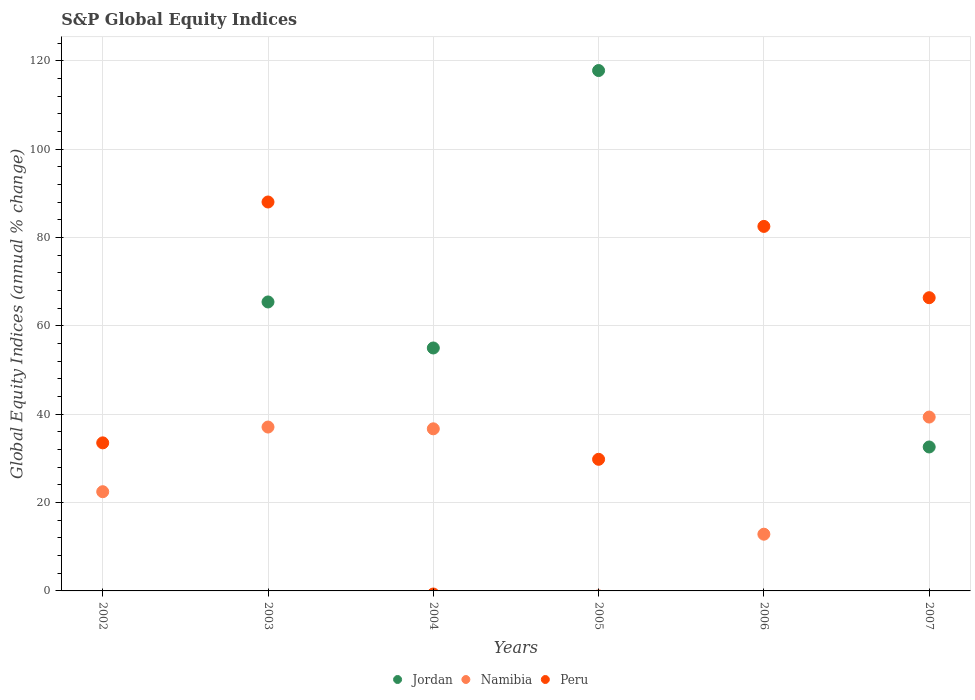How many different coloured dotlines are there?
Provide a short and direct response. 3. Is the number of dotlines equal to the number of legend labels?
Keep it short and to the point. No. Across all years, what is the maximum global equity indices in Namibia?
Make the answer very short. 39.36. What is the total global equity indices in Peru in the graph?
Your answer should be compact. 300.28. What is the difference between the global equity indices in Jordan in 2003 and that in 2004?
Your answer should be very brief. 10.42. What is the difference between the global equity indices in Namibia in 2006 and the global equity indices in Peru in 2007?
Provide a succinct answer. -53.54. What is the average global equity indices in Peru per year?
Make the answer very short. 50.05. In the year 2003, what is the difference between the global equity indices in Namibia and global equity indices in Jordan?
Offer a terse response. -28.32. What is the ratio of the global equity indices in Peru in 2002 to that in 2006?
Give a very brief answer. 0.41. Is the global equity indices in Jordan in 2003 less than that in 2005?
Your answer should be compact. Yes. What is the difference between the highest and the second highest global equity indices in Peru?
Your answer should be compact. 5.52. What is the difference between the highest and the lowest global equity indices in Jordan?
Give a very brief answer. 117.81. Is the sum of the global equity indices in Jordan in 2003 and 2004 greater than the maximum global equity indices in Peru across all years?
Keep it short and to the point. Yes. Is it the case that in every year, the sum of the global equity indices in Namibia and global equity indices in Jordan  is greater than the global equity indices in Peru?
Make the answer very short. No. Does the graph contain grids?
Ensure brevity in your answer.  Yes. Where does the legend appear in the graph?
Offer a very short reply. Bottom center. How many legend labels are there?
Provide a short and direct response. 3. What is the title of the graph?
Offer a very short reply. S&P Global Equity Indices. Does "Venezuela" appear as one of the legend labels in the graph?
Give a very brief answer. No. What is the label or title of the Y-axis?
Give a very brief answer. Global Equity Indices (annual % change). What is the Global Equity Indices (annual % change) in Jordan in 2002?
Provide a succinct answer. 0. What is the Global Equity Indices (annual % change) in Namibia in 2002?
Provide a short and direct response. 22.46. What is the Global Equity Indices (annual % change) in Peru in 2002?
Your answer should be compact. 33.52. What is the Global Equity Indices (annual % change) of Jordan in 2003?
Provide a succinct answer. 65.42. What is the Global Equity Indices (annual % change) in Namibia in 2003?
Provide a short and direct response. 37.1. What is the Global Equity Indices (annual % change) of Peru in 2003?
Offer a very short reply. 88.05. What is the Global Equity Indices (annual % change) in Jordan in 2004?
Offer a very short reply. 55. What is the Global Equity Indices (annual % change) of Namibia in 2004?
Provide a short and direct response. 36.7. What is the Global Equity Indices (annual % change) in Jordan in 2005?
Ensure brevity in your answer.  117.81. What is the Global Equity Indices (annual % change) in Namibia in 2005?
Your answer should be compact. 0. What is the Global Equity Indices (annual % change) of Peru in 2005?
Your response must be concise. 29.8. What is the Global Equity Indices (annual % change) of Namibia in 2006?
Offer a very short reply. 12.84. What is the Global Equity Indices (annual % change) of Peru in 2006?
Give a very brief answer. 82.53. What is the Global Equity Indices (annual % change) in Jordan in 2007?
Offer a very short reply. 32.59. What is the Global Equity Indices (annual % change) of Namibia in 2007?
Provide a succinct answer. 39.36. What is the Global Equity Indices (annual % change) of Peru in 2007?
Make the answer very short. 66.38. Across all years, what is the maximum Global Equity Indices (annual % change) in Jordan?
Provide a succinct answer. 117.81. Across all years, what is the maximum Global Equity Indices (annual % change) in Namibia?
Keep it short and to the point. 39.36. Across all years, what is the maximum Global Equity Indices (annual % change) of Peru?
Your answer should be compact. 88.05. Across all years, what is the minimum Global Equity Indices (annual % change) in Jordan?
Ensure brevity in your answer.  0. What is the total Global Equity Indices (annual % change) in Jordan in the graph?
Provide a short and direct response. 270.82. What is the total Global Equity Indices (annual % change) in Namibia in the graph?
Offer a very short reply. 148.46. What is the total Global Equity Indices (annual % change) in Peru in the graph?
Provide a short and direct response. 300.28. What is the difference between the Global Equity Indices (annual % change) in Namibia in 2002 and that in 2003?
Provide a short and direct response. -14.64. What is the difference between the Global Equity Indices (annual % change) of Peru in 2002 and that in 2003?
Offer a very short reply. -54.53. What is the difference between the Global Equity Indices (annual % change) in Namibia in 2002 and that in 2004?
Your answer should be very brief. -14.24. What is the difference between the Global Equity Indices (annual % change) of Peru in 2002 and that in 2005?
Offer a very short reply. 3.72. What is the difference between the Global Equity Indices (annual % change) of Namibia in 2002 and that in 2006?
Keep it short and to the point. 9.62. What is the difference between the Global Equity Indices (annual % change) of Peru in 2002 and that in 2006?
Your answer should be compact. -49.01. What is the difference between the Global Equity Indices (annual % change) in Namibia in 2002 and that in 2007?
Your answer should be very brief. -16.9. What is the difference between the Global Equity Indices (annual % change) in Peru in 2002 and that in 2007?
Provide a short and direct response. -32.86. What is the difference between the Global Equity Indices (annual % change) of Jordan in 2003 and that in 2004?
Offer a very short reply. 10.42. What is the difference between the Global Equity Indices (annual % change) in Jordan in 2003 and that in 2005?
Provide a succinct answer. -52.39. What is the difference between the Global Equity Indices (annual % change) of Peru in 2003 and that in 2005?
Offer a terse response. 58.25. What is the difference between the Global Equity Indices (annual % change) in Namibia in 2003 and that in 2006?
Keep it short and to the point. 24.26. What is the difference between the Global Equity Indices (annual % change) in Peru in 2003 and that in 2006?
Your answer should be compact. 5.52. What is the difference between the Global Equity Indices (annual % change) in Jordan in 2003 and that in 2007?
Ensure brevity in your answer.  32.83. What is the difference between the Global Equity Indices (annual % change) of Namibia in 2003 and that in 2007?
Give a very brief answer. -2.26. What is the difference between the Global Equity Indices (annual % change) of Peru in 2003 and that in 2007?
Your response must be concise. 21.67. What is the difference between the Global Equity Indices (annual % change) of Jordan in 2004 and that in 2005?
Offer a terse response. -62.81. What is the difference between the Global Equity Indices (annual % change) of Namibia in 2004 and that in 2006?
Your response must be concise. 23.86. What is the difference between the Global Equity Indices (annual % change) of Jordan in 2004 and that in 2007?
Provide a succinct answer. 22.41. What is the difference between the Global Equity Indices (annual % change) in Namibia in 2004 and that in 2007?
Give a very brief answer. -2.66. What is the difference between the Global Equity Indices (annual % change) of Peru in 2005 and that in 2006?
Provide a succinct answer. -52.73. What is the difference between the Global Equity Indices (annual % change) of Jordan in 2005 and that in 2007?
Offer a very short reply. 85.23. What is the difference between the Global Equity Indices (annual % change) of Peru in 2005 and that in 2007?
Provide a succinct answer. -36.59. What is the difference between the Global Equity Indices (annual % change) of Namibia in 2006 and that in 2007?
Offer a terse response. -26.52. What is the difference between the Global Equity Indices (annual % change) in Peru in 2006 and that in 2007?
Offer a terse response. 16.14. What is the difference between the Global Equity Indices (annual % change) in Namibia in 2002 and the Global Equity Indices (annual % change) in Peru in 2003?
Provide a succinct answer. -65.59. What is the difference between the Global Equity Indices (annual % change) in Namibia in 2002 and the Global Equity Indices (annual % change) in Peru in 2005?
Your answer should be very brief. -7.34. What is the difference between the Global Equity Indices (annual % change) of Namibia in 2002 and the Global Equity Indices (annual % change) of Peru in 2006?
Your answer should be compact. -60.07. What is the difference between the Global Equity Indices (annual % change) in Namibia in 2002 and the Global Equity Indices (annual % change) in Peru in 2007?
Provide a short and direct response. -43.92. What is the difference between the Global Equity Indices (annual % change) in Jordan in 2003 and the Global Equity Indices (annual % change) in Namibia in 2004?
Provide a short and direct response. 28.72. What is the difference between the Global Equity Indices (annual % change) of Jordan in 2003 and the Global Equity Indices (annual % change) of Peru in 2005?
Ensure brevity in your answer.  35.62. What is the difference between the Global Equity Indices (annual % change) of Namibia in 2003 and the Global Equity Indices (annual % change) of Peru in 2005?
Keep it short and to the point. 7.3. What is the difference between the Global Equity Indices (annual % change) of Jordan in 2003 and the Global Equity Indices (annual % change) of Namibia in 2006?
Your answer should be very brief. 52.58. What is the difference between the Global Equity Indices (annual % change) of Jordan in 2003 and the Global Equity Indices (annual % change) of Peru in 2006?
Provide a succinct answer. -17.11. What is the difference between the Global Equity Indices (annual % change) in Namibia in 2003 and the Global Equity Indices (annual % change) in Peru in 2006?
Your answer should be compact. -45.43. What is the difference between the Global Equity Indices (annual % change) in Jordan in 2003 and the Global Equity Indices (annual % change) in Namibia in 2007?
Provide a succinct answer. 26.06. What is the difference between the Global Equity Indices (annual % change) of Jordan in 2003 and the Global Equity Indices (annual % change) of Peru in 2007?
Your response must be concise. -0.96. What is the difference between the Global Equity Indices (annual % change) in Namibia in 2003 and the Global Equity Indices (annual % change) in Peru in 2007?
Your answer should be compact. -29.28. What is the difference between the Global Equity Indices (annual % change) in Jordan in 2004 and the Global Equity Indices (annual % change) in Peru in 2005?
Your answer should be compact. 25.2. What is the difference between the Global Equity Indices (annual % change) in Namibia in 2004 and the Global Equity Indices (annual % change) in Peru in 2005?
Provide a succinct answer. 6.9. What is the difference between the Global Equity Indices (annual % change) of Jordan in 2004 and the Global Equity Indices (annual % change) of Namibia in 2006?
Provide a succinct answer. 42.16. What is the difference between the Global Equity Indices (annual % change) of Jordan in 2004 and the Global Equity Indices (annual % change) of Peru in 2006?
Give a very brief answer. -27.53. What is the difference between the Global Equity Indices (annual % change) of Namibia in 2004 and the Global Equity Indices (annual % change) of Peru in 2006?
Provide a short and direct response. -45.83. What is the difference between the Global Equity Indices (annual % change) in Jordan in 2004 and the Global Equity Indices (annual % change) in Namibia in 2007?
Make the answer very short. 15.64. What is the difference between the Global Equity Indices (annual % change) of Jordan in 2004 and the Global Equity Indices (annual % change) of Peru in 2007?
Your response must be concise. -11.38. What is the difference between the Global Equity Indices (annual % change) in Namibia in 2004 and the Global Equity Indices (annual % change) in Peru in 2007?
Your answer should be very brief. -29.68. What is the difference between the Global Equity Indices (annual % change) of Jordan in 2005 and the Global Equity Indices (annual % change) of Namibia in 2006?
Give a very brief answer. 104.97. What is the difference between the Global Equity Indices (annual % change) in Jordan in 2005 and the Global Equity Indices (annual % change) in Peru in 2006?
Offer a terse response. 35.29. What is the difference between the Global Equity Indices (annual % change) of Jordan in 2005 and the Global Equity Indices (annual % change) of Namibia in 2007?
Your answer should be very brief. 78.45. What is the difference between the Global Equity Indices (annual % change) of Jordan in 2005 and the Global Equity Indices (annual % change) of Peru in 2007?
Your answer should be compact. 51.43. What is the difference between the Global Equity Indices (annual % change) of Namibia in 2006 and the Global Equity Indices (annual % change) of Peru in 2007?
Give a very brief answer. -53.54. What is the average Global Equity Indices (annual % change) in Jordan per year?
Your answer should be very brief. 45.14. What is the average Global Equity Indices (annual % change) in Namibia per year?
Offer a very short reply. 24.74. What is the average Global Equity Indices (annual % change) in Peru per year?
Offer a very short reply. 50.05. In the year 2002, what is the difference between the Global Equity Indices (annual % change) of Namibia and Global Equity Indices (annual % change) of Peru?
Offer a very short reply. -11.06. In the year 2003, what is the difference between the Global Equity Indices (annual % change) of Jordan and Global Equity Indices (annual % change) of Namibia?
Your answer should be compact. 28.32. In the year 2003, what is the difference between the Global Equity Indices (annual % change) in Jordan and Global Equity Indices (annual % change) in Peru?
Your answer should be compact. -22.63. In the year 2003, what is the difference between the Global Equity Indices (annual % change) in Namibia and Global Equity Indices (annual % change) in Peru?
Offer a terse response. -50.95. In the year 2005, what is the difference between the Global Equity Indices (annual % change) of Jordan and Global Equity Indices (annual % change) of Peru?
Ensure brevity in your answer.  88.02. In the year 2006, what is the difference between the Global Equity Indices (annual % change) in Namibia and Global Equity Indices (annual % change) in Peru?
Provide a succinct answer. -69.68. In the year 2007, what is the difference between the Global Equity Indices (annual % change) of Jordan and Global Equity Indices (annual % change) of Namibia?
Offer a very short reply. -6.77. In the year 2007, what is the difference between the Global Equity Indices (annual % change) in Jordan and Global Equity Indices (annual % change) in Peru?
Offer a terse response. -33.8. In the year 2007, what is the difference between the Global Equity Indices (annual % change) of Namibia and Global Equity Indices (annual % change) of Peru?
Offer a terse response. -27.02. What is the ratio of the Global Equity Indices (annual % change) in Namibia in 2002 to that in 2003?
Ensure brevity in your answer.  0.61. What is the ratio of the Global Equity Indices (annual % change) in Peru in 2002 to that in 2003?
Your response must be concise. 0.38. What is the ratio of the Global Equity Indices (annual % change) in Namibia in 2002 to that in 2004?
Offer a very short reply. 0.61. What is the ratio of the Global Equity Indices (annual % change) in Peru in 2002 to that in 2005?
Your response must be concise. 1.12. What is the ratio of the Global Equity Indices (annual % change) of Namibia in 2002 to that in 2006?
Ensure brevity in your answer.  1.75. What is the ratio of the Global Equity Indices (annual % change) of Peru in 2002 to that in 2006?
Offer a terse response. 0.41. What is the ratio of the Global Equity Indices (annual % change) in Namibia in 2002 to that in 2007?
Your answer should be very brief. 0.57. What is the ratio of the Global Equity Indices (annual % change) in Peru in 2002 to that in 2007?
Make the answer very short. 0.5. What is the ratio of the Global Equity Indices (annual % change) in Jordan in 2003 to that in 2004?
Make the answer very short. 1.19. What is the ratio of the Global Equity Indices (annual % change) in Namibia in 2003 to that in 2004?
Your answer should be compact. 1.01. What is the ratio of the Global Equity Indices (annual % change) of Jordan in 2003 to that in 2005?
Offer a very short reply. 0.56. What is the ratio of the Global Equity Indices (annual % change) of Peru in 2003 to that in 2005?
Offer a terse response. 2.96. What is the ratio of the Global Equity Indices (annual % change) of Namibia in 2003 to that in 2006?
Give a very brief answer. 2.89. What is the ratio of the Global Equity Indices (annual % change) in Peru in 2003 to that in 2006?
Offer a terse response. 1.07. What is the ratio of the Global Equity Indices (annual % change) of Jordan in 2003 to that in 2007?
Make the answer very short. 2.01. What is the ratio of the Global Equity Indices (annual % change) of Namibia in 2003 to that in 2007?
Keep it short and to the point. 0.94. What is the ratio of the Global Equity Indices (annual % change) of Peru in 2003 to that in 2007?
Make the answer very short. 1.33. What is the ratio of the Global Equity Indices (annual % change) in Jordan in 2004 to that in 2005?
Your answer should be very brief. 0.47. What is the ratio of the Global Equity Indices (annual % change) in Namibia in 2004 to that in 2006?
Provide a short and direct response. 2.86. What is the ratio of the Global Equity Indices (annual % change) of Jordan in 2004 to that in 2007?
Keep it short and to the point. 1.69. What is the ratio of the Global Equity Indices (annual % change) in Namibia in 2004 to that in 2007?
Offer a very short reply. 0.93. What is the ratio of the Global Equity Indices (annual % change) of Peru in 2005 to that in 2006?
Provide a succinct answer. 0.36. What is the ratio of the Global Equity Indices (annual % change) of Jordan in 2005 to that in 2007?
Offer a very short reply. 3.62. What is the ratio of the Global Equity Indices (annual % change) of Peru in 2005 to that in 2007?
Ensure brevity in your answer.  0.45. What is the ratio of the Global Equity Indices (annual % change) in Namibia in 2006 to that in 2007?
Keep it short and to the point. 0.33. What is the ratio of the Global Equity Indices (annual % change) of Peru in 2006 to that in 2007?
Provide a succinct answer. 1.24. What is the difference between the highest and the second highest Global Equity Indices (annual % change) in Jordan?
Ensure brevity in your answer.  52.39. What is the difference between the highest and the second highest Global Equity Indices (annual % change) in Namibia?
Provide a succinct answer. 2.26. What is the difference between the highest and the second highest Global Equity Indices (annual % change) in Peru?
Provide a short and direct response. 5.52. What is the difference between the highest and the lowest Global Equity Indices (annual % change) in Jordan?
Your answer should be very brief. 117.81. What is the difference between the highest and the lowest Global Equity Indices (annual % change) of Namibia?
Offer a very short reply. 39.36. What is the difference between the highest and the lowest Global Equity Indices (annual % change) of Peru?
Make the answer very short. 88.05. 